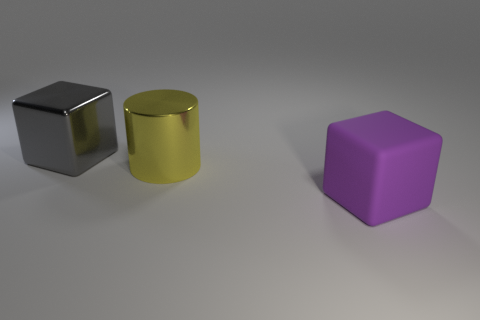Add 3 small cyan matte cubes. How many objects exist? 6 Subtract all cylinders. How many objects are left? 2 Subtract all small yellow spheres. Subtract all gray metal blocks. How many objects are left? 2 Add 2 purple things. How many purple things are left? 3 Add 3 large purple things. How many large purple things exist? 4 Subtract 0 brown blocks. How many objects are left? 3 